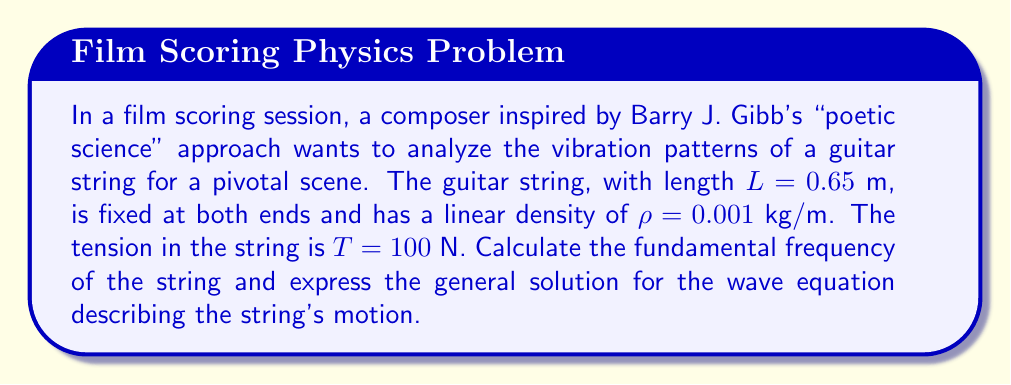What is the answer to this math problem? To solve this problem, we'll use the wave equation for a vibrating string and follow these steps:

1) The wave equation for a vibrating string is:

   $$\frac{\partial^2 y}{\partial t^2} = c^2 \frac{\partial^2 y}{\partial x^2}$$

   where $c$ is the wave speed.

2) The wave speed $c$ is given by:

   $$c = \sqrt{\frac{T}{\rho}}$$

   Substituting the given values:
   $$c = \sqrt{\frac{100}{0.001}} = 316.23 \text{ m/s}$$

3) The fundamental frequency $f_1$ of a string of length $L$ is:

   $$f_1 = \frac{c}{2L}$$

   Substituting our values:
   $$f_1 = \frac{316.23}{2(0.65)} = 243.25 \text{ Hz}$$

4) The general solution to the wave equation for a string fixed at both ends is:

   $$y(x,t) = \sum_{n=1}^{\infty} A_n \sin(\frac{n\pi x}{L}) \cos(\frac{n\pi c t}{L})$$

   where $A_n$ are the amplitudes of the harmonic components, determined by initial conditions.

5) We can express the angular frequency $\omega_n$ for each harmonic:

   $$\omega_n = \frac{n\pi c}{L} = n\omega_1$$

   where $\omega_1 = 2\pi f_1 = 1528.41 \text{ rad/s}$

Thus, we have found the fundamental frequency and expressed the general solution for the wave equation describing the string's motion.
Answer: The fundamental frequency is 243.25 Hz. The general solution for the wave equation is:

$$y(x,t) = \sum_{n=1}^{\infty} A_n \sin(\frac{n\pi x}{0.65}) \cos(1528.41nt)$$ 